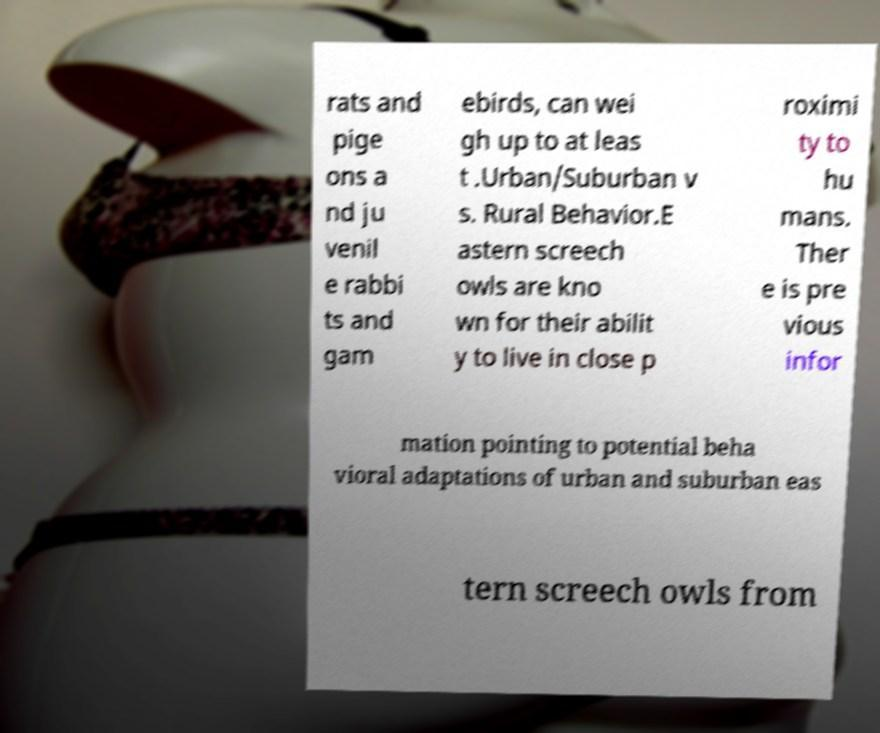There's text embedded in this image that I need extracted. Can you transcribe it verbatim? rats and pige ons a nd ju venil e rabbi ts and gam ebirds, can wei gh up to at leas t .Urban/Suburban v s. Rural Behavior.E astern screech owls are kno wn for their abilit y to live in close p roximi ty to hu mans. Ther e is pre vious infor mation pointing to potential beha vioral adaptations of urban and suburban eas tern screech owls from 